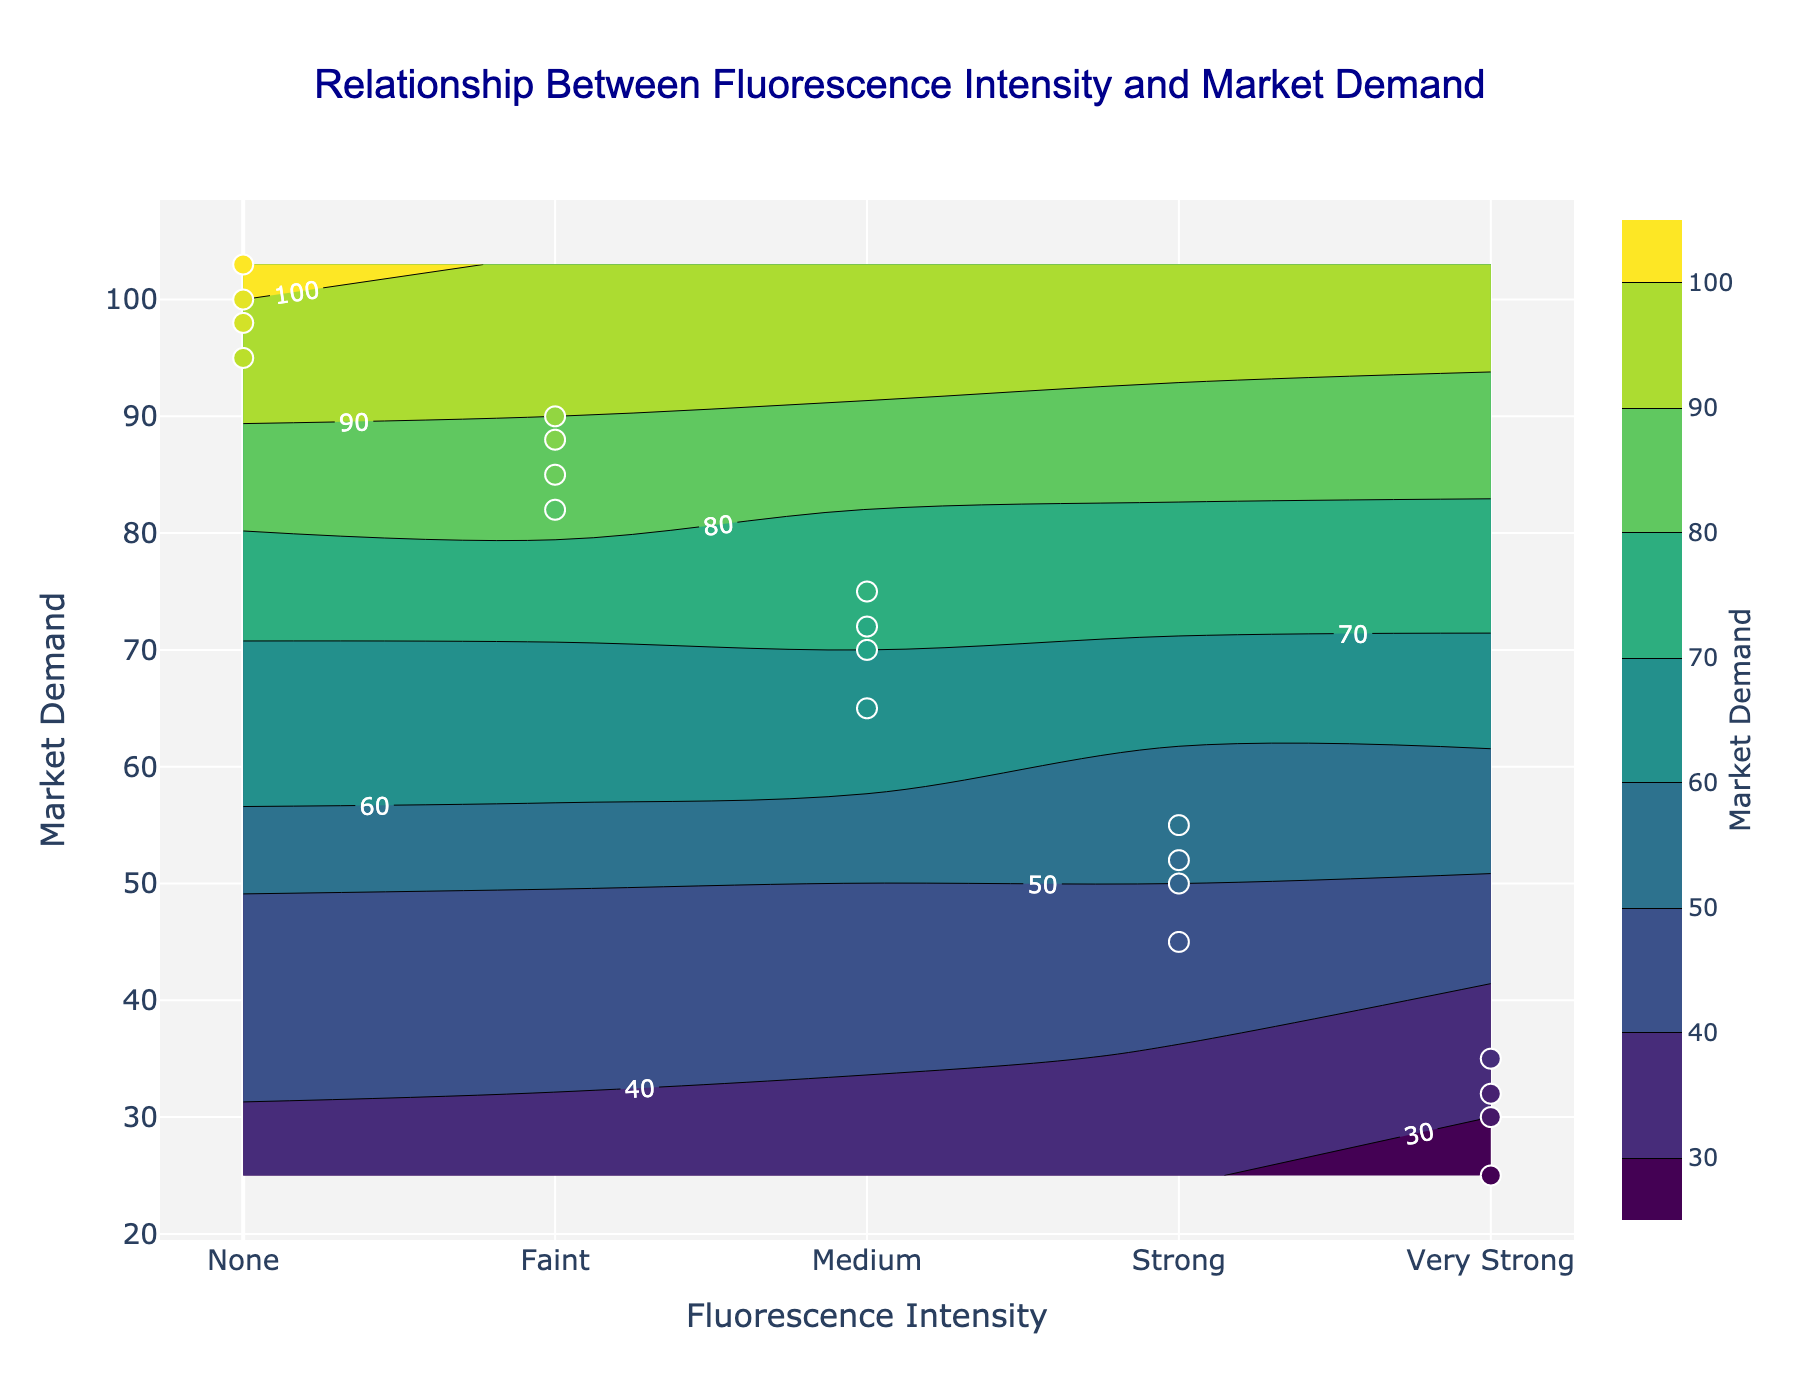What is the title of the figure? The title of the figure is located at the top and states what the figure is about. In this case, the title is 'Relationship Between Fluorescence Intensity and Market Demand'.
Answer: Relationship Between Fluorescence Intensity and Market Demand What are the different fluorescence intensity levels shown in the figure? The fluorescence intensity levels are marked on the x-axis, and they include: None, Faint, Medium, Strong, Very Strong.
Answer: None, Faint, Medium, Strong, Very Strong Which fluorescence intensity level has the highest market demand? The y-axis represents the market demand, and the 'None' fluorescence intensity level shows the highest values in terms of market demand.
Answer: None How do market demands compare between 'Medium' and 'Strong' fluorescence intensity levels? To compare, we look at the market demand values for each level. 'Medium' has demands ranging around 70s, while 'Strong' has demands ranging around 50s, so 'Medium' has higher market demand than 'Strong'.
Answer: Medium has higher market demand than Strong What is the average market demand for 'Faint' fluorescence intensity? There are multiple data points for 'Faint' intensity. Summing them up (85 + 82 + 90 + 88) gives 345. Dividing by 4 (number of data points) gives us an average demand of 86.25.
Answer: 86.25 Is there a visible trend between fluorescence intensity and market demand? By observing the contour plot, it is clear that as fluorescence intensity increases from None to Very Strong, the market demand generally decreases.
Answer: Demand decreases as intensity increases Which intensity level has the lowest market demand, and what is the value? By checking the contour and points, 'Very Strong' intensity has the lowest market demand, with specific values hovering around 30.
Answer: Very Strong; around 30 How many fluorescence intensity levels are within the market demand range of 70 to 100? Scanning the y-axis within 70-100 range, we can see 'None', 'Faint', and 'Medium' are all within this range based on the contour lines and scatter points.
Answer: Three levels (None, Faint, Medium) What is the market demand for 'Strong' fluorescence intensity on average? The demand values for 'Strong' are 50, 45, 55, and 52. Summing these gives 202, divided by 4 gives an average of 50.5.
Answer: 50.5 